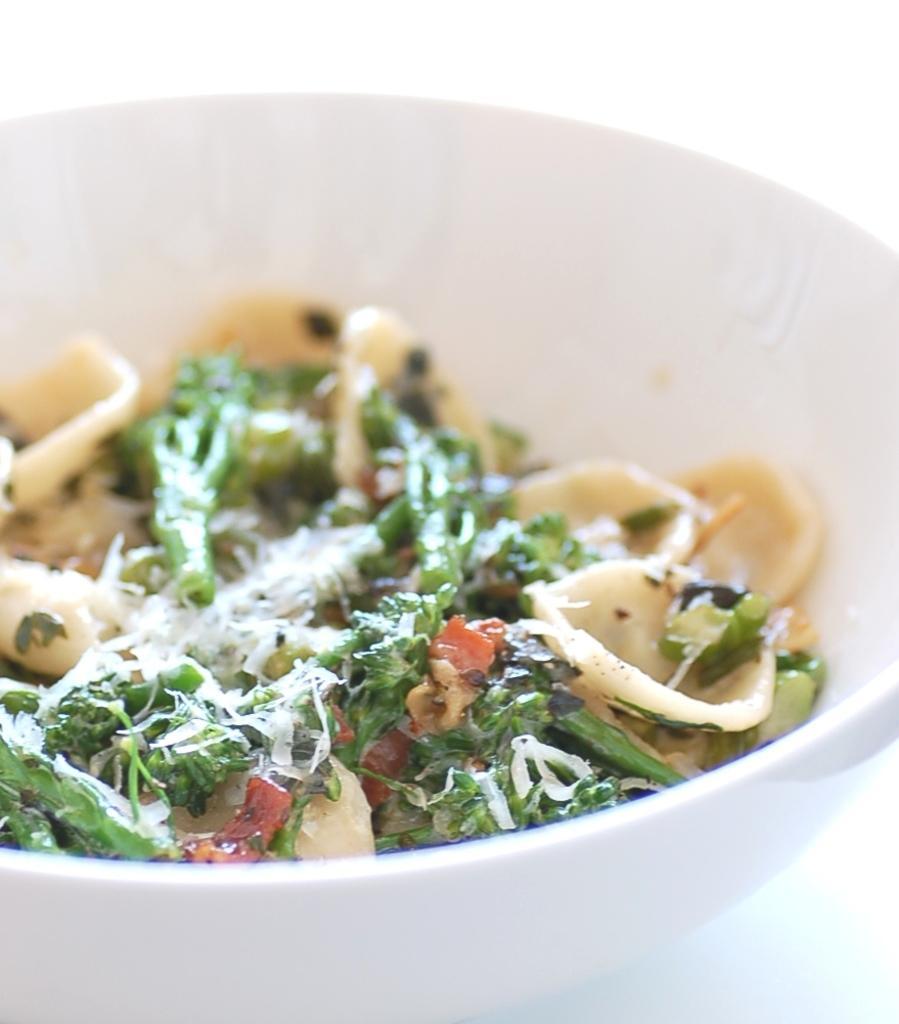Can you describe this image briefly? There is a white bowl with some food items. 